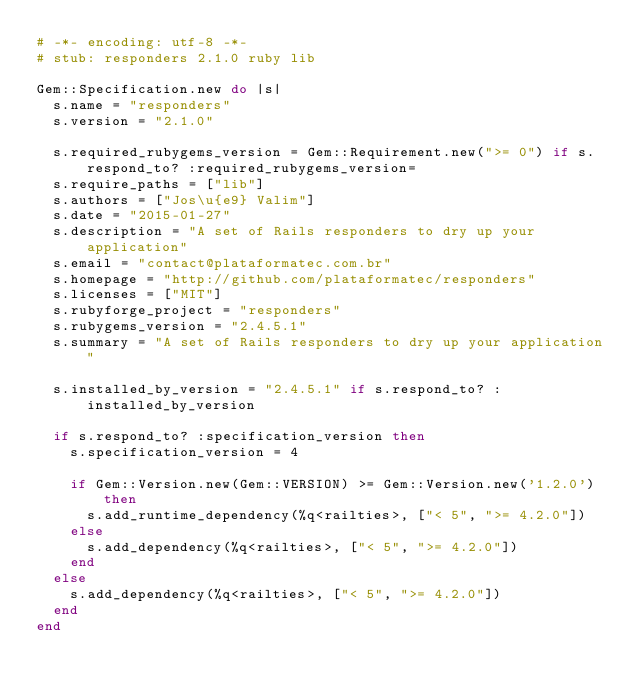<code> <loc_0><loc_0><loc_500><loc_500><_Ruby_># -*- encoding: utf-8 -*-
# stub: responders 2.1.0 ruby lib

Gem::Specification.new do |s|
  s.name = "responders"
  s.version = "2.1.0"

  s.required_rubygems_version = Gem::Requirement.new(">= 0") if s.respond_to? :required_rubygems_version=
  s.require_paths = ["lib"]
  s.authors = ["Jos\u{e9} Valim"]
  s.date = "2015-01-27"
  s.description = "A set of Rails responders to dry up your application"
  s.email = "contact@plataformatec.com.br"
  s.homepage = "http://github.com/plataformatec/responders"
  s.licenses = ["MIT"]
  s.rubyforge_project = "responders"
  s.rubygems_version = "2.4.5.1"
  s.summary = "A set of Rails responders to dry up your application"

  s.installed_by_version = "2.4.5.1" if s.respond_to? :installed_by_version

  if s.respond_to? :specification_version then
    s.specification_version = 4

    if Gem::Version.new(Gem::VERSION) >= Gem::Version.new('1.2.0') then
      s.add_runtime_dependency(%q<railties>, ["< 5", ">= 4.2.0"])
    else
      s.add_dependency(%q<railties>, ["< 5", ">= 4.2.0"])
    end
  else
    s.add_dependency(%q<railties>, ["< 5", ">= 4.2.0"])
  end
end
</code> 